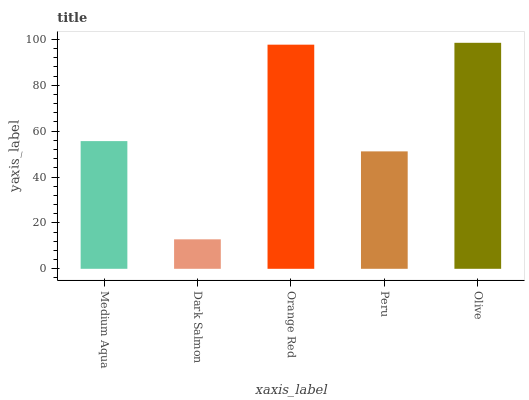Is Dark Salmon the minimum?
Answer yes or no. Yes. Is Olive the maximum?
Answer yes or no. Yes. Is Orange Red the minimum?
Answer yes or no. No. Is Orange Red the maximum?
Answer yes or no. No. Is Orange Red greater than Dark Salmon?
Answer yes or no. Yes. Is Dark Salmon less than Orange Red?
Answer yes or no. Yes. Is Dark Salmon greater than Orange Red?
Answer yes or no. No. Is Orange Red less than Dark Salmon?
Answer yes or no. No. Is Medium Aqua the high median?
Answer yes or no. Yes. Is Medium Aqua the low median?
Answer yes or no. Yes. Is Orange Red the high median?
Answer yes or no. No. Is Orange Red the low median?
Answer yes or no. No. 